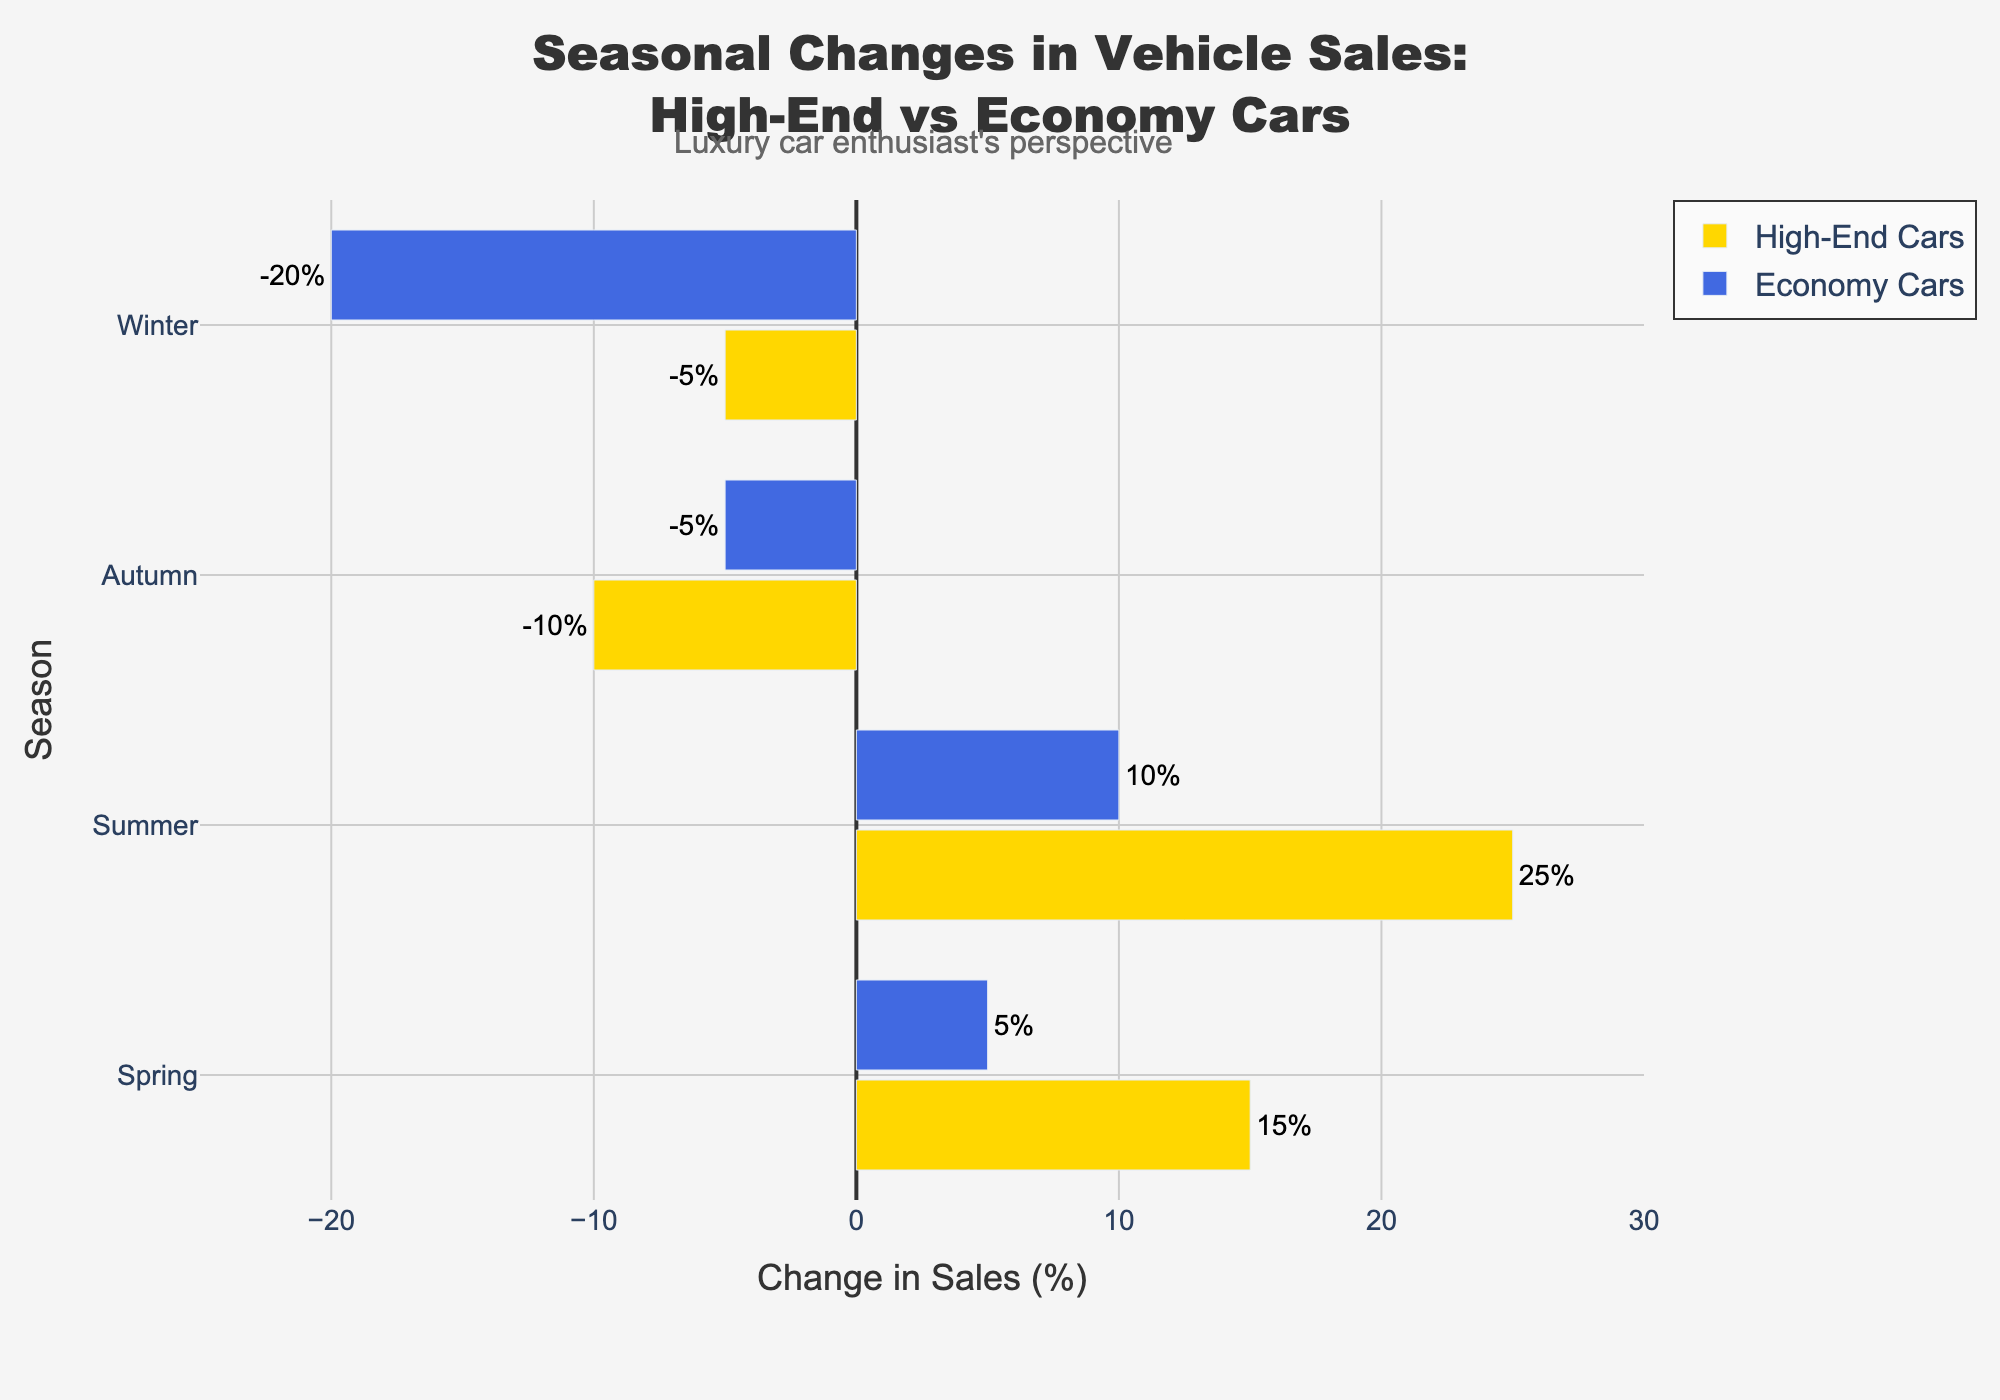Which season shows the highest increase in sales for high-end cars? Look at the bar lengths for high-end cars and identify the season with the longest positive bar. Summer has the highest increase in sales for high-end cars at 25%.
Answer: Summer Which season experiences the greatest decrease in sales for economy cars? Identify the season with the longest negative bar for economy cars. Winter shows the greatest decrease with -20%.
Answer: Winter What is the difference in sales change between high-end cars and economy cars during autumn? Subtract the sales change of economy cars from that of high-end cars in autumn: -10% - (-5%) = -5%.
Answer: -5% In which season do both high-end and economy cars experience a decrease in sales? Identify the seasons where both car types have negative bars. Both high-end and economy cars experience a decrease in autumn and winter.
Answer: Autumn and Winter By how much do high-end car sales exceed economy car sales in the summer? Subtract the sales change for economy cars from that for high-end cars in summer: 25% - 10% = 15%.
Answer: 15% Which vehicle type has a more stable trend across the seasons? Compare the range of changes for both vehicle types. Economy cars range from -20% to 10%, while high-end cars range from -10% to 25%. High-end cars have a larger range indicating less stability.
Answer: Economy Cars Which season shows the smallest positive increase in sales for economy cars? Identify the shortest positive bar for economy cars. Spring shows the smallest positive increase at 5%.
Answer: Spring How do the sales of high-end cars in spring compare to those in autumn? Compare the bar lengths for high-end cars in spring (15%) and autumn (-10%). Spring has a higher sales change than autumn.
Answer: Spring has higher sales Calculate the total change in sales across all seasons for high-end cars. Sum the sales changes for high-end cars across all seasons: 15% + 25% - 10% - 5% = 25%.
Answer: 25% Which season shows the highest difference in sales change between high-end and economy cars? Calculate the differences for each season: Spring (15% - 5% = 10%), Summer (25% - 10% = 15%), Autumn (-10% - (-5%) = -5%), Winter (-5% - (-20%) = 15%). Summer and winter both have the highest difference of 15%.
Answer: Summer and Winter 